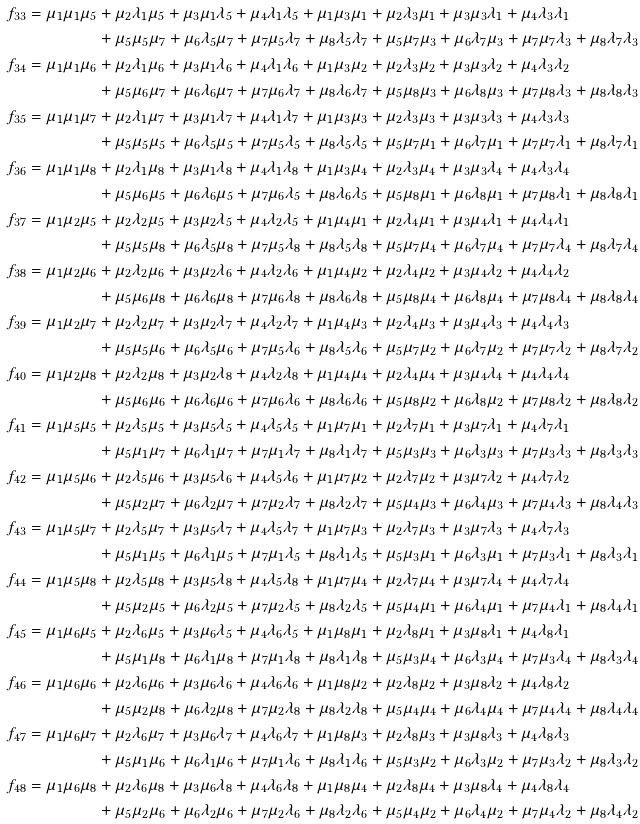Convert formula to latex. <formula><loc_0><loc_0><loc_500><loc_500>f _ { 3 3 } = \mu _ { 1 } \mu _ { 1 } \mu _ { 5 } & + \mu _ { 2 } \lambda _ { 1 } \mu _ { 5 } + \mu _ { 3 } \mu _ { 1 } \lambda _ { 5 } + \mu _ { 4 } \lambda _ { 1 } \lambda _ { 5 } + \mu _ { 1 } \mu _ { 3 } \mu _ { 1 } + \mu _ { 2 } \lambda _ { 3 } \mu _ { 1 } + \mu _ { 3 } \mu _ { 3 } \lambda _ { 1 } + \mu _ { 4 } \lambda _ { 3 } \lambda _ { 1 } \\ & + \mu _ { 5 } \mu _ { 5 } \mu _ { 7 } + \mu _ { 6 } \lambda _ { 5 } \mu _ { 7 } + \mu _ { 7 } \mu _ { 5 } \lambda _ { 7 } + \mu _ { 8 } \lambda _ { 5 } \lambda _ { 7 } + \mu _ { 5 } \mu _ { 7 } \mu _ { 3 } + \mu _ { 6 } \lambda _ { 7 } \mu _ { 3 } + \mu _ { 7 } \mu _ { 7 } \lambda _ { 3 } + \mu _ { 8 } \lambda _ { 7 } \lambda _ { 3 } \\ f _ { 3 4 } = \mu _ { 1 } \mu _ { 1 } \mu _ { 6 } & + \mu _ { 2 } \lambda _ { 1 } \mu _ { 6 } + \mu _ { 3 } \mu _ { 1 } \lambda _ { 6 } + \mu _ { 4 } \lambda _ { 1 } \lambda _ { 6 } + \mu _ { 1 } \mu _ { 3 } \mu _ { 2 } + \mu _ { 2 } \lambda _ { 3 } \mu _ { 2 } + \mu _ { 3 } \mu _ { 3 } \lambda _ { 2 } + \mu _ { 4 } \lambda _ { 3 } \lambda _ { 2 } \\ & + \mu _ { 5 } \mu _ { 6 } \mu _ { 7 } + \mu _ { 6 } \lambda _ { 6 } \mu _ { 7 } + \mu _ { 7 } \mu _ { 6 } \lambda _ { 7 } + \mu _ { 8 } \lambda _ { 6 } \lambda _ { 7 } + \mu _ { 5 } \mu _ { 8 } \mu _ { 3 } + \mu _ { 6 } \lambda _ { 8 } \mu _ { 3 } + \mu _ { 7 } \mu _ { 8 } \lambda _ { 3 } + \mu _ { 8 } \lambda _ { 8 } \lambda _ { 3 } \\ f _ { 3 5 } = \mu _ { 1 } \mu _ { 1 } \mu _ { 7 } & + \mu _ { 2 } \lambda _ { 1 } \mu _ { 7 } + \mu _ { 3 } \mu _ { 1 } \lambda _ { 7 } + \mu _ { 4 } \lambda _ { 1 } \lambda _ { 7 } + \mu _ { 1 } \mu _ { 3 } \mu _ { 3 } + \mu _ { 2 } \lambda _ { 3 } \mu _ { 3 } + \mu _ { 3 } \mu _ { 3 } \lambda _ { 3 } + \mu _ { 4 } \lambda _ { 3 } \lambda _ { 3 } \\ & + \mu _ { 5 } \mu _ { 5 } \mu _ { 5 } + \mu _ { 6 } \lambda _ { 5 } \mu _ { 5 } + \mu _ { 7 } \mu _ { 5 } \lambda _ { 5 } + \mu _ { 8 } \lambda _ { 5 } \lambda _ { 5 } + \mu _ { 5 } \mu _ { 7 } \mu _ { 1 } + \mu _ { 6 } \lambda _ { 7 } \mu _ { 1 } + \mu _ { 7 } \mu _ { 7 } \lambda _ { 1 } + \mu _ { 8 } \lambda _ { 7 } \lambda _ { 1 } \\ f _ { 3 6 } = \mu _ { 1 } \mu _ { 1 } \mu _ { 8 } & + \mu _ { 2 } \lambda _ { 1 } \mu _ { 8 } + \mu _ { 3 } \mu _ { 1 } \lambda _ { 8 } + \mu _ { 4 } \lambda _ { 1 } \lambda _ { 8 } + \mu _ { 1 } \mu _ { 3 } \mu _ { 4 } + \mu _ { 2 } \lambda _ { 3 } \mu _ { 4 } + \mu _ { 3 } \mu _ { 3 } \lambda _ { 4 } + \mu _ { 4 } \lambda _ { 3 } \lambda _ { 4 } \\ & + \mu _ { 5 } \mu _ { 6 } \mu _ { 5 } + \mu _ { 6 } \lambda _ { 6 } \mu _ { 5 } + \mu _ { 7 } \mu _ { 6 } \lambda _ { 5 } + \mu _ { 8 } \lambda _ { 6 } \lambda _ { 5 } + \mu _ { 5 } \mu _ { 8 } \mu _ { 1 } + \mu _ { 6 } \lambda _ { 8 } \mu _ { 1 } + \mu _ { 7 } \mu _ { 8 } \lambda _ { 1 } + \mu _ { 8 } \lambda _ { 8 } \lambda _ { 1 } \\ f _ { 3 7 } = \mu _ { 1 } \mu _ { 2 } \mu _ { 5 } & + \mu _ { 2 } \lambda _ { 2 } \mu _ { 5 } + \mu _ { 3 } \mu _ { 2 } \lambda _ { 5 } + \mu _ { 4 } \lambda _ { 2 } \lambda _ { 5 } + \mu _ { 1 } \mu _ { 4 } \mu _ { 1 } + \mu _ { 2 } \lambda _ { 4 } \mu _ { 1 } + \mu _ { 3 } \mu _ { 4 } \lambda _ { 1 } + \mu _ { 4 } \lambda _ { 4 } \lambda _ { 1 } \\ & + \mu _ { 5 } \mu _ { 5 } \mu _ { 8 } + \mu _ { 6 } \lambda _ { 5 } \mu _ { 8 } + \mu _ { 7 } \mu _ { 5 } \lambda _ { 8 } + \mu _ { 8 } \lambda _ { 5 } \lambda _ { 8 } + \mu _ { 5 } \mu _ { 7 } \mu _ { 4 } + \mu _ { 6 } \lambda _ { 7 } \mu _ { 4 } + \mu _ { 7 } \mu _ { 7 } \lambda _ { 4 } + \mu _ { 8 } \lambda _ { 7 } \lambda _ { 4 } \\ f _ { 3 8 } = \mu _ { 1 } \mu _ { 2 } \mu _ { 6 } & + \mu _ { 2 } \lambda _ { 2 } \mu _ { 6 } + \mu _ { 3 } \mu _ { 2 } \lambda _ { 6 } + \mu _ { 4 } \lambda _ { 2 } \lambda _ { 6 } + \mu _ { 1 } \mu _ { 4 } \mu _ { 2 } + \mu _ { 2 } \lambda _ { 4 } \mu _ { 2 } + \mu _ { 3 } \mu _ { 4 } \lambda _ { 2 } + \mu _ { 4 } \lambda _ { 4 } \lambda _ { 2 } \\ & + \mu _ { 5 } \mu _ { 6 } \mu _ { 8 } + \mu _ { 6 } \lambda _ { 6 } \mu _ { 8 } + \mu _ { 7 } \mu _ { 6 } \lambda _ { 8 } + \mu _ { 8 } \lambda _ { 6 } \lambda _ { 8 } + \mu _ { 5 } \mu _ { 8 } \mu _ { 4 } + \mu _ { 6 } \lambda _ { 8 } \mu _ { 4 } + \mu _ { 7 } \mu _ { 8 } \lambda _ { 4 } + \mu _ { 8 } \lambda _ { 8 } \lambda _ { 4 } \\ f _ { 3 9 } = \mu _ { 1 } \mu _ { 2 } \mu _ { 7 } & + \mu _ { 2 } \lambda _ { 2 } \mu _ { 7 } + \mu _ { 3 } \mu _ { 2 } \lambda _ { 7 } + \mu _ { 4 } \lambda _ { 2 } \lambda _ { 7 } + \mu _ { 1 } \mu _ { 4 } \mu _ { 3 } + \mu _ { 2 } \lambda _ { 4 } \mu _ { 3 } + \mu _ { 3 } \mu _ { 4 } \lambda _ { 3 } + \mu _ { 4 } \lambda _ { 4 } \lambda _ { 3 } \\ & + \mu _ { 5 } \mu _ { 5 } \mu _ { 6 } + \mu _ { 6 } \lambda _ { 5 } \mu _ { 6 } + \mu _ { 7 } \mu _ { 5 } \lambda _ { 6 } + \mu _ { 8 } \lambda _ { 5 } \lambda _ { 6 } + \mu _ { 5 } \mu _ { 7 } \mu _ { 2 } + \mu _ { 6 } \lambda _ { 7 } \mu _ { 2 } + \mu _ { 7 } \mu _ { 7 } \lambda _ { 2 } + \mu _ { 8 } \lambda _ { 7 } \lambda _ { 2 } \\ f _ { 4 0 } = \mu _ { 1 } \mu _ { 2 } \mu _ { 8 } & + \mu _ { 2 } \lambda _ { 2 } \mu _ { 8 } + \mu _ { 3 } \mu _ { 2 } \lambda _ { 8 } + \mu _ { 4 } \lambda _ { 2 } \lambda _ { 8 } + \mu _ { 1 } \mu _ { 4 } \mu _ { 4 } + \mu _ { 2 } \lambda _ { 4 } \mu _ { 4 } + \mu _ { 3 } \mu _ { 4 } \lambda _ { 4 } + \mu _ { 4 } \lambda _ { 4 } \lambda _ { 4 } \\ & + \mu _ { 5 } \mu _ { 6 } \mu _ { 6 } + \mu _ { 6 } \lambda _ { 6 } \mu _ { 6 } + \mu _ { 7 } \mu _ { 6 } \lambda _ { 6 } + \mu _ { 8 } \lambda _ { 6 } \lambda _ { 6 } + \mu _ { 5 } \mu _ { 8 } \mu _ { 2 } + \mu _ { 6 } \lambda _ { 8 } \mu _ { 2 } + \mu _ { 7 } \mu _ { 8 } \lambda _ { 2 } + \mu _ { 8 } \lambda _ { 8 } \lambda _ { 2 } \\ f _ { 4 1 } = \mu _ { 1 } \mu _ { 5 } \mu _ { 5 } & + \mu _ { 2 } \lambda _ { 5 } \mu _ { 5 } + \mu _ { 3 } \mu _ { 5 } \lambda _ { 5 } + \mu _ { 4 } \lambda _ { 5 } \lambda _ { 5 } + \mu _ { 1 } \mu _ { 7 } \mu _ { 1 } + \mu _ { 2 } \lambda _ { 7 } \mu _ { 1 } + \mu _ { 3 } \mu _ { 7 } \lambda _ { 1 } + \mu _ { 4 } \lambda _ { 7 } \lambda _ { 1 } \\ & + \mu _ { 5 } \mu _ { 1 } \mu _ { 7 } + \mu _ { 6 } \lambda _ { 1 } \mu _ { 7 } + \mu _ { 7 } \mu _ { 1 } \lambda _ { 7 } + \mu _ { 8 } \lambda _ { 1 } \lambda _ { 7 } + \mu _ { 5 } \mu _ { 3 } \mu _ { 3 } + \mu _ { 6 } \lambda _ { 3 } \mu _ { 3 } + \mu _ { 7 } \mu _ { 3 } \lambda _ { 3 } + \mu _ { 8 } \lambda _ { 3 } \lambda _ { 3 } \\ f _ { 4 2 } = \mu _ { 1 } \mu _ { 5 } \mu _ { 6 } & + \mu _ { 2 } \lambda _ { 5 } \mu _ { 6 } + \mu _ { 3 } \mu _ { 5 } \lambda _ { 6 } + \mu _ { 4 } \lambda _ { 5 } \lambda _ { 6 } + \mu _ { 1 } \mu _ { 7 } \mu _ { 2 } + \mu _ { 2 } \lambda _ { 7 } \mu _ { 2 } + \mu _ { 3 } \mu _ { 7 } \lambda _ { 2 } + \mu _ { 4 } \lambda _ { 7 } \lambda _ { 2 } \\ & + \mu _ { 5 } \mu _ { 2 } \mu _ { 7 } + \mu _ { 6 } \lambda _ { 2 } \mu _ { 7 } + \mu _ { 7 } \mu _ { 2 } \lambda _ { 7 } + \mu _ { 8 } \lambda _ { 2 } \lambda _ { 7 } + \mu _ { 5 } \mu _ { 4 } \mu _ { 3 } + \mu _ { 6 } \lambda _ { 4 } \mu _ { 3 } + \mu _ { 7 } \mu _ { 4 } \lambda _ { 3 } + \mu _ { 8 } \lambda _ { 4 } \lambda _ { 3 } \\ f _ { 4 3 } = \mu _ { 1 } \mu _ { 5 } \mu _ { 7 } & + \mu _ { 2 } \lambda _ { 5 } \mu _ { 7 } + \mu _ { 3 } \mu _ { 5 } \lambda _ { 7 } + \mu _ { 4 } \lambda _ { 5 } \lambda _ { 7 } + \mu _ { 1 } \mu _ { 7 } \mu _ { 3 } + \mu _ { 2 } \lambda _ { 7 } \mu _ { 3 } + \mu _ { 3 } \mu _ { 7 } \lambda _ { 3 } + \mu _ { 4 } \lambda _ { 7 } \lambda _ { 3 } \\ & + \mu _ { 5 } \mu _ { 1 } \mu _ { 5 } + \mu _ { 6 } \lambda _ { 1 } \mu _ { 5 } + \mu _ { 7 } \mu _ { 1 } \lambda _ { 5 } + \mu _ { 8 } \lambda _ { 1 } \lambda _ { 5 } + \mu _ { 5 } \mu _ { 3 } \mu _ { 1 } + \mu _ { 6 } \lambda _ { 3 } \mu _ { 1 } + \mu _ { 7 } \mu _ { 3 } \lambda _ { 1 } + \mu _ { 8 } \lambda _ { 3 } \lambda _ { 1 } \\ f _ { 4 4 } = \mu _ { 1 } \mu _ { 5 } \mu _ { 8 } & + \mu _ { 2 } \lambda _ { 5 } \mu _ { 8 } + \mu _ { 3 } \mu _ { 5 } \lambda _ { 8 } + \mu _ { 4 } \lambda _ { 5 } \lambda _ { 8 } + \mu _ { 1 } \mu _ { 7 } \mu _ { 4 } + \mu _ { 2 } \lambda _ { 7 } \mu _ { 4 } + \mu _ { 3 } \mu _ { 7 } \lambda _ { 4 } + \mu _ { 4 } \lambda _ { 7 } \lambda _ { 4 } \\ & + \mu _ { 5 } \mu _ { 2 } \mu _ { 5 } + \mu _ { 6 } \lambda _ { 2 } \mu _ { 5 } + \mu _ { 7 } \mu _ { 2 } \lambda _ { 5 } + \mu _ { 8 } \lambda _ { 2 } \lambda _ { 5 } + \mu _ { 5 } \mu _ { 4 } \mu _ { 1 } + \mu _ { 6 } \lambda _ { 4 } \mu _ { 1 } + \mu _ { 7 } \mu _ { 4 } \lambda _ { 1 } + \mu _ { 8 } \lambda _ { 4 } \lambda _ { 1 } \\ f _ { 4 5 } = \mu _ { 1 } \mu _ { 6 } \mu _ { 5 } & + \mu _ { 2 } \lambda _ { 6 } \mu _ { 5 } + \mu _ { 3 } \mu _ { 6 } \lambda _ { 5 } + \mu _ { 4 } \lambda _ { 6 } \lambda _ { 5 } + \mu _ { 1 } \mu _ { 8 } \mu _ { 1 } + \mu _ { 2 } \lambda _ { 8 } \mu _ { 1 } + \mu _ { 3 } \mu _ { 8 } \lambda _ { 1 } + \mu _ { 4 } \lambda _ { 8 } \lambda _ { 1 } \\ & + \mu _ { 5 } \mu _ { 1 } \mu _ { 8 } + \mu _ { 6 } \lambda _ { 1 } \mu _ { 8 } + \mu _ { 7 } \mu _ { 1 } \lambda _ { 8 } + \mu _ { 8 } \lambda _ { 1 } \lambda _ { 8 } + \mu _ { 5 } \mu _ { 3 } \mu _ { 4 } + \mu _ { 6 } \lambda _ { 3 } \mu _ { 4 } + \mu _ { 7 } \mu _ { 3 } \lambda _ { 4 } + \mu _ { 8 } \lambda _ { 3 } \lambda _ { 4 } \\ f _ { 4 6 } = \mu _ { 1 } \mu _ { 6 } \mu _ { 6 } & + \mu _ { 2 } \lambda _ { 6 } \mu _ { 6 } + \mu _ { 3 } \mu _ { 6 } \lambda _ { 6 } + \mu _ { 4 } \lambda _ { 6 } \lambda _ { 6 } + \mu _ { 1 } \mu _ { 8 } \mu _ { 2 } + \mu _ { 2 } \lambda _ { 8 } \mu _ { 2 } + \mu _ { 3 } \mu _ { 8 } \lambda _ { 2 } + \mu _ { 4 } \lambda _ { 8 } \lambda _ { 2 } \\ & + \mu _ { 5 } \mu _ { 2 } \mu _ { 8 } + \mu _ { 6 } \lambda _ { 2 } \mu _ { 8 } + \mu _ { 7 } \mu _ { 2 } \lambda _ { 8 } + \mu _ { 8 } \lambda _ { 2 } \lambda _ { 8 } + \mu _ { 5 } \mu _ { 4 } \mu _ { 4 } + \mu _ { 6 } \lambda _ { 4 } \mu _ { 4 } + \mu _ { 7 } \mu _ { 4 } \lambda _ { 4 } + \mu _ { 8 } \lambda _ { 4 } \lambda _ { 4 } \\ f _ { 4 7 } = \mu _ { 1 } \mu _ { 6 } \mu _ { 7 } & + \mu _ { 2 } \lambda _ { 6 } \mu _ { 7 } + \mu _ { 3 } \mu _ { 6 } \lambda _ { 7 } + \mu _ { 4 } \lambda _ { 6 } \lambda _ { 7 } + \mu _ { 1 } \mu _ { 8 } \mu _ { 3 } + \mu _ { 2 } \lambda _ { 8 } \mu _ { 3 } + \mu _ { 3 } \mu _ { 8 } \lambda _ { 3 } + \mu _ { 4 } \lambda _ { 8 } \lambda _ { 3 } \\ & + \mu _ { 5 } \mu _ { 1 } \mu _ { 6 } + \mu _ { 6 } \lambda _ { 1 } \mu _ { 6 } + \mu _ { 7 } \mu _ { 1 } \lambda _ { 6 } + \mu _ { 8 } \lambda _ { 1 } \lambda _ { 6 } + \mu _ { 5 } \mu _ { 3 } \mu _ { 2 } + \mu _ { 6 } \lambda _ { 3 } \mu _ { 2 } + \mu _ { 7 } \mu _ { 3 } \lambda _ { 2 } + \mu _ { 8 } \lambda _ { 3 } \lambda _ { 2 } \\ f _ { 4 8 } = \mu _ { 1 } \mu _ { 6 } \mu _ { 8 } & + \mu _ { 2 } \lambda _ { 6 } \mu _ { 8 } + \mu _ { 3 } \mu _ { 6 } \lambda _ { 8 } + \mu _ { 4 } \lambda _ { 6 } \lambda _ { 8 } + \mu _ { 1 } \mu _ { 8 } \mu _ { 4 } + \mu _ { 2 } \lambda _ { 8 } \mu _ { 4 } + \mu _ { 3 } \mu _ { 8 } \lambda _ { 4 } + \mu _ { 4 } \lambda _ { 8 } \lambda _ { 4 } \\ & + \mu _ { 5 } \mu _ { 2 } \mu _ { 6 } + \mu _ { 6 } \lambda _ { 2 } \mu _ { 6 } + \mu _ { 7 } \mu _ { 2 } \lambda _ { 6 } + \mu _ { 8 } \lambda _ { 2 } \lambda _ { 6 } + \mu _ { 5 } \mu _ { 4 } \mu _ { 2 } + \mu _ { 6 } \lambda _ { 4 } \mu _ { 2 } + \mu _ { 7 } \mu _ { 4 } \lambda _ { 2 } + \mu _ { 8 } \lambda _ { 4 } \lambda _ { 2 }</formula> 